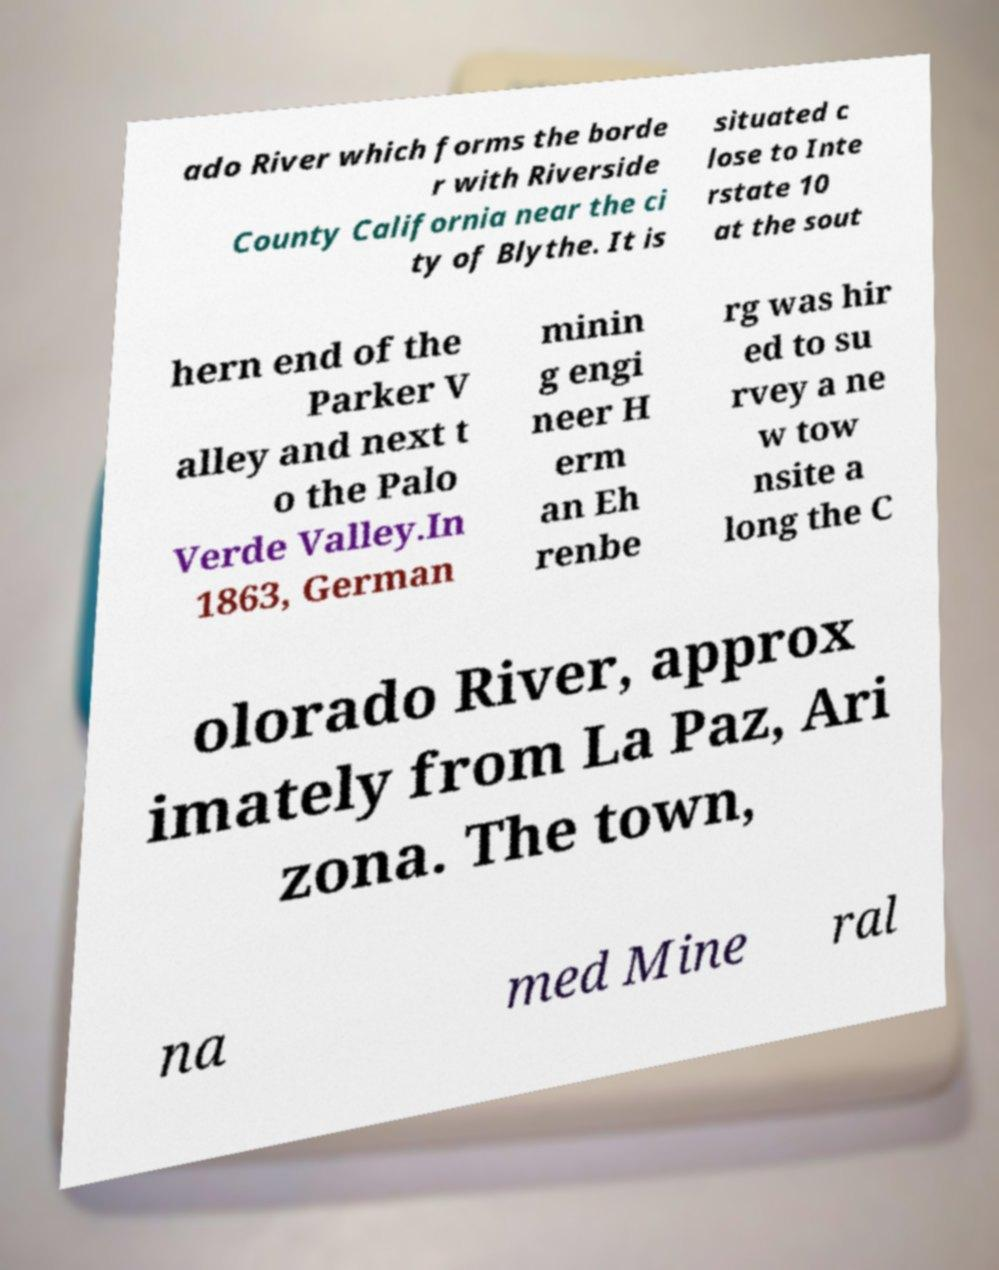What messages or text are displayed in this image? I need them in a readable, typed format. ado River which forms the borde r with Riverside County California near the ci ty of Blythe. It is situated c lose to Inte rstate 10 at the sout hern end of the Parker V alley and next t o the Palo Verde Valley.In 1863, German minin g engi neer H erm an Eh renbe rg was hir ed to su rvey a ne w tow nsite a long the C olorado River, approx imately from La Paz, Ari zona. The town, na med Mine ral 